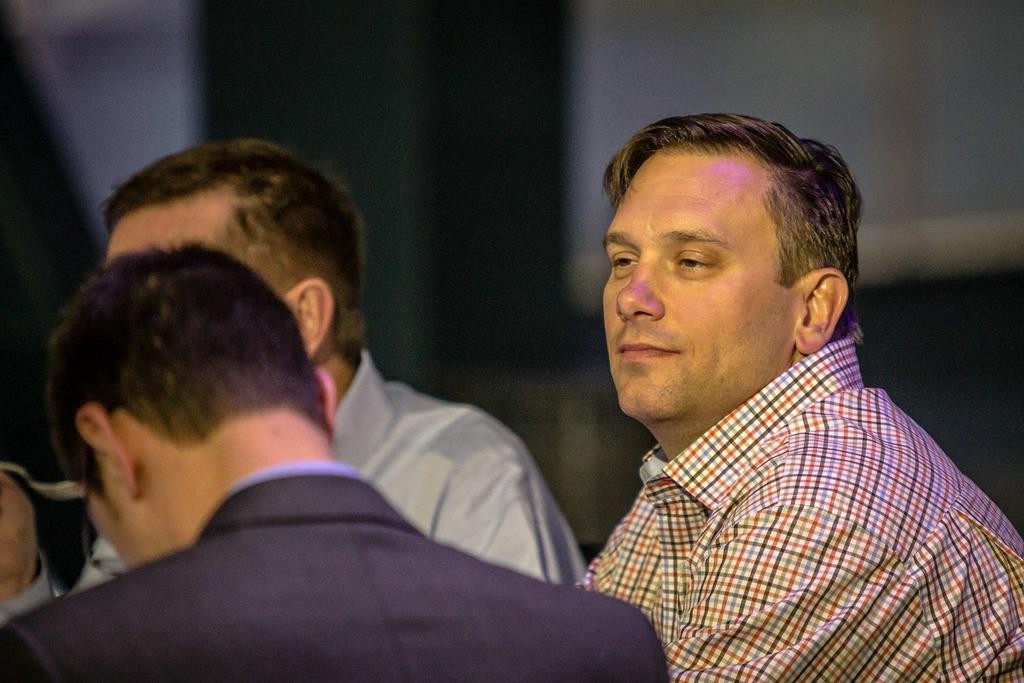Who or what can be seen in the image? There are people in the image. What can be observed about the background of the image? The background of the image is blurred. What type of magic is being performed by the people in the image? There is no indication of magic or any magical activity in the image. 